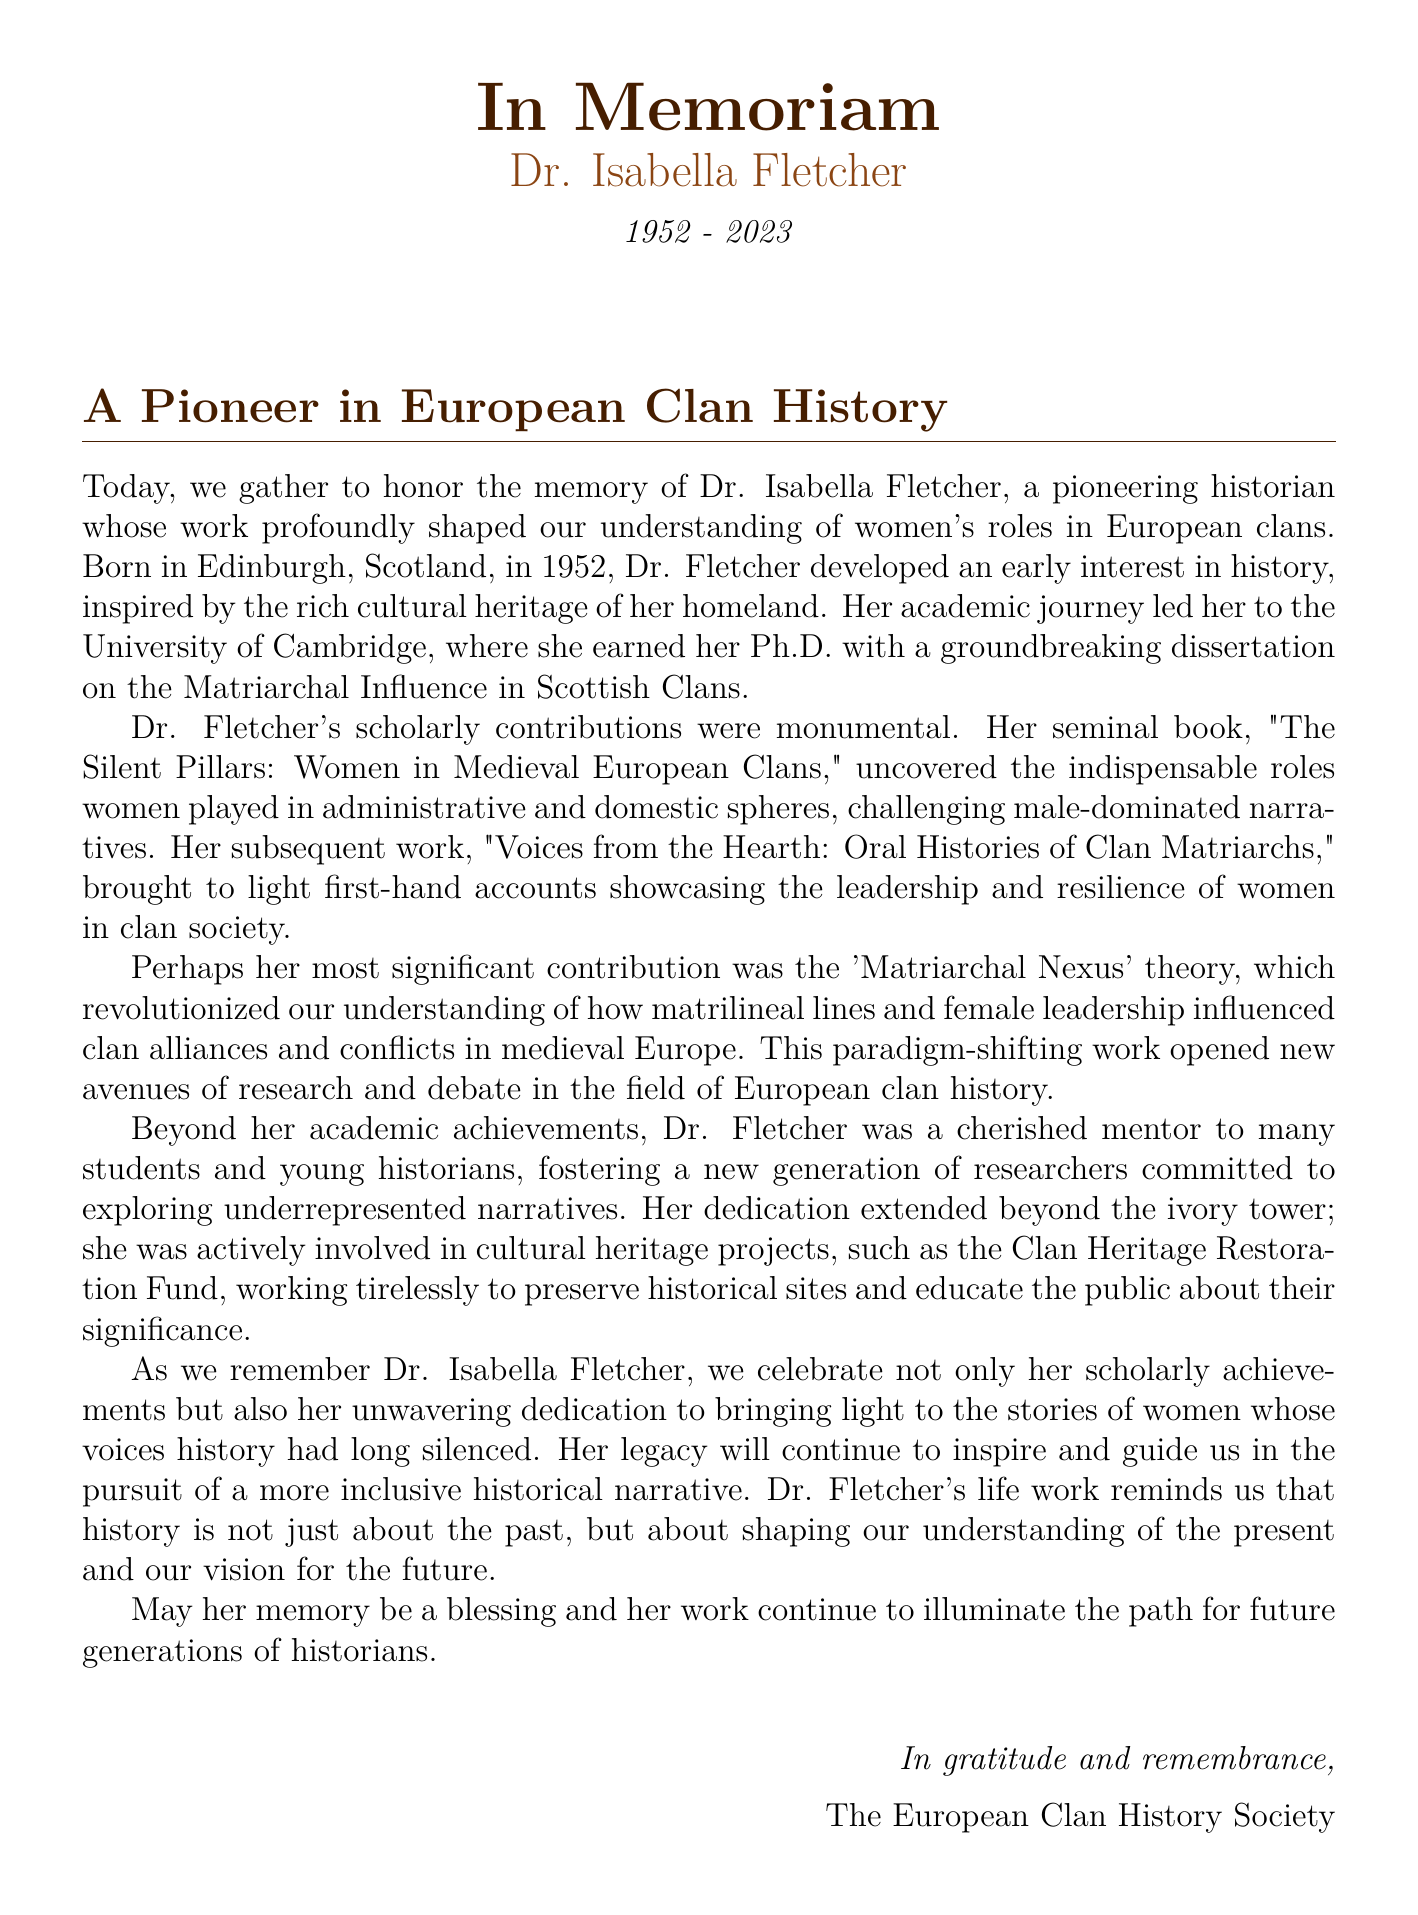What is the full name of the historian being honored? The document introduces the historian as Dr. Isabella Fletcher, who is the subject of the eulogy.
Answer: Dr. Isabella Fletcher What year was Dr. Isabella Fletcher born? The document states that Dr. Fletcher was born in 1952.
Answer: 1952 What is the title of Dr. Fletcher's seminal book? The eulogy highlights Dr. Fletcher's important work, which is titled "The Silent Pillars: Women in Medieval European Clans."
Answer: The Silent Pillars: Women in Medieval European Clans What theory did Dr. Fletcher develop that influenced the field of clan history? The document mentions her 'Matriarchal Nexus' theory, which significantly impacted the understanding of women in clans.
Answer: Matriarchal Nexus Which university did Dr. Fletcher attend for her Ph.D.? The eulogy indicates that Dr. Fletcher earned her degree from the University of Cambridge.
Answer: University of Cambridge How old was Dr. Fletcher when she passed away? The document notes that Dr. Fletcher was born in 1952 and passed away in 2023, allowing us to calculate her age at death.
Answer: 71 What was the purpose of the Clan Heritage Restoration Fund mentioned in the document? The document explains that the fund aims to preserve historical sites and educate the public about their significance.
Answer: Preserve historical sites What did Dr. Fletcher bring to light through her oral histories? The eulogy describes her work as showcasing the leadership and resilience of women in clan society.
Answer: Leadership and resilience What is the main theme of the eulogy? The document emphasizes honoring Dr. Fletcher's contributions to understanding women's roles in European clans and her legacy in the field.
Answer: Women's roles in European clans 